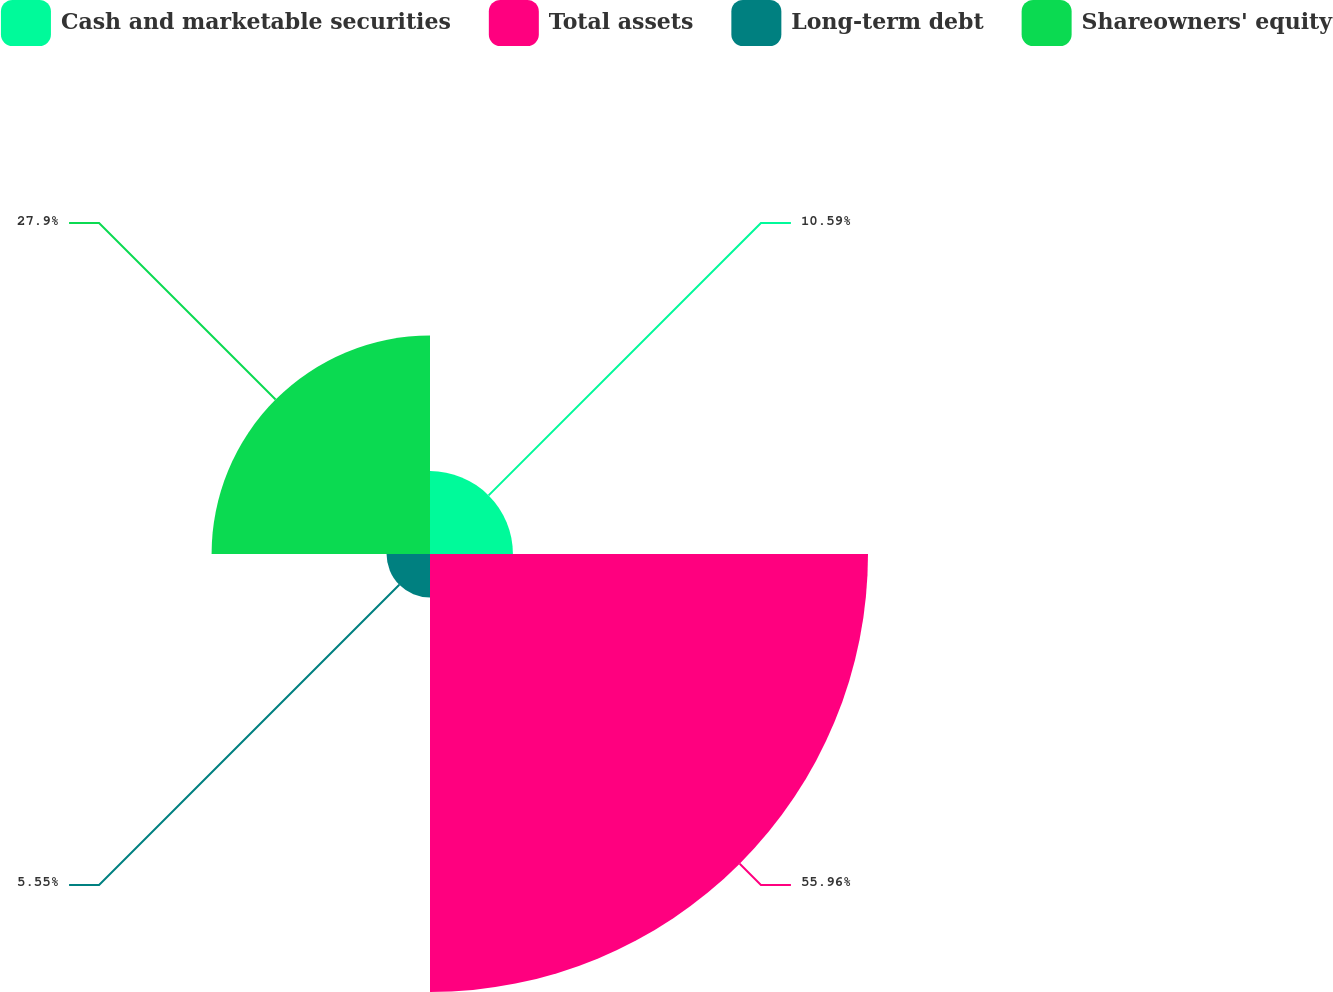<chart> <loc_0><loc_0><loc_500><loc_500><pie_chart><fcel>Cash and marketable securities<fcel>Total assets<fcel>Long-term debt<fcel>Shareowners' equity<nl><fcel>10.59%<fcel>55.95%<fcel>5.55%<fcel>27.9%<nl></chart> 